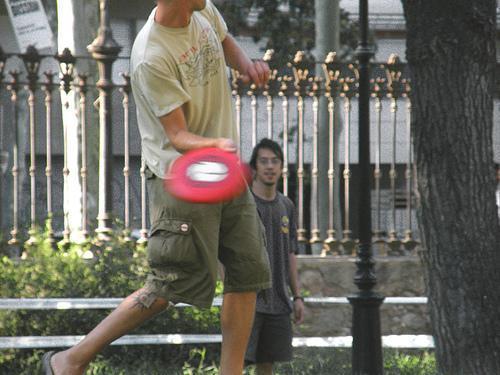How many people are in the photo?
Give a very brief answer. 2. How many people are there?
Give a very brief answer. 2. 